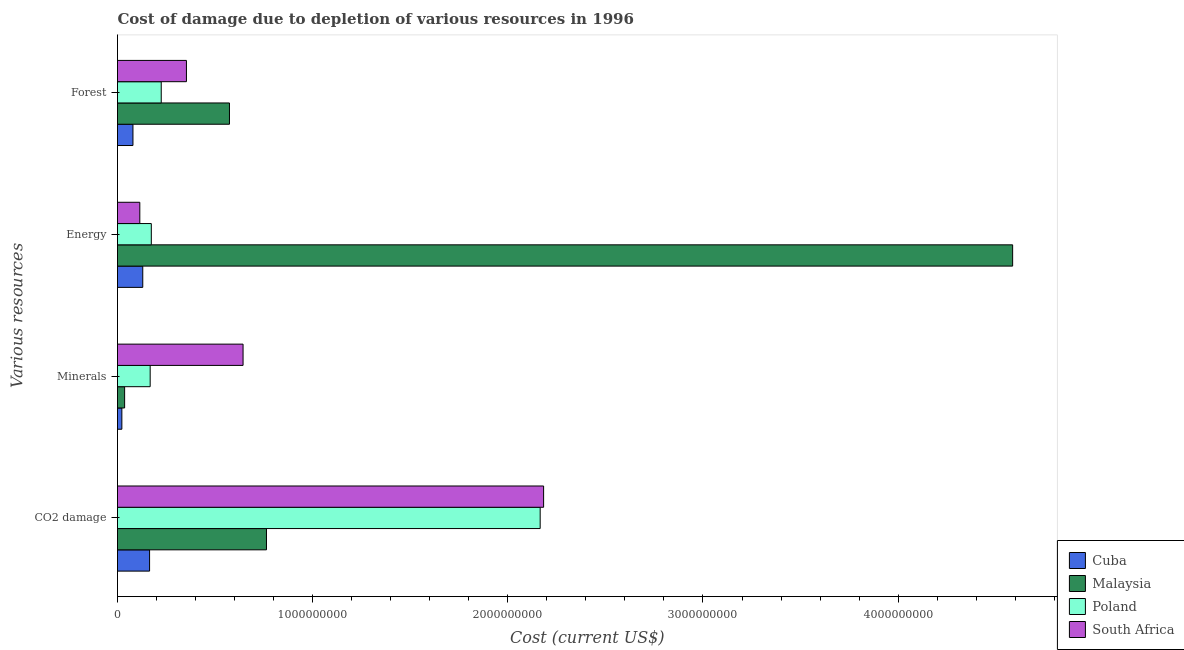Are the number of bars per tick equal to the number of legend labels?
Make the answer very short. Yes. Are the number of bars on each tick of the Y-axis equal?
Provide a succinct answer. Yes. How many bars are there on the 2nd tick from the top?
Provide a short and direct response. 4. How many bars are there on the 2nd tick from the bottom?
Offer a terse response. 4. What is the label of the 2nd group of bars from the top?
Make the answer very short. Energy. What is the cost of damage due to depletion of minerals in Malaysia?
Keep it short and to the point. 3.65e+07. Across all countries, what is the maximum cost of damage due to depletion of coal?
Your response must be concise. 2.18e+09. Across all countries, what is the minimum cost of damage due to depletion of coal?
Offer a terse response. 1.64e+08. In which country was the cost of damage due to depletion of minerals maximum?
Ensure brevity in your answer.  South Africa. In which country was the cost of damage due to depletion of forests minimum?
Offer a terse response. Cuba. What is the total cost of damage due to depletion of energy in the graph?
Your response must be concise. 5.00e+09. What is the difference between the cost of damage due to depletion of minerals in Cuba and that in Poland?
Your answer should be compact. -1.45e+08. What is the difference between the cost of damage due to depletion of minerals in Cuba and the cost of damage due to depletion of forests in Poland?
Provide a short and direct response. -2.02e+08. What is the average cost of damage due to depletion of minerals per country?
Your response must be concise. 2.17e+08. What is the difference between the cost of damage due to depletion of forests and cost of damage due to depletion of minerals in Cuba?
Provide a succinct answer. 5.68e+07. What is the ratio of the cost of damage due to depletion of energy in South Africa to that in Cuba?
Ensure brevity in your answer.  0.88. Is the difference between the cost of damage due to depletion of energy in Poland and South Africa greater than the difference between the cost of damage due to depletion of coal in Poland and South Africa?
Offer a very short reply. Yes. What is the difference between the highest and the second highest cost of damage due to depletion of energy?
Your response must be concise. 4.41e+09. What is the difference between the highest and the lowest cost of damage due to depletion of minerals?
Provide a short and direct response. 6.21e+08. Is it the case that in every country, the sum of the cost of damage due to depletion of energy and cost of damage due to depletion of coal is greater than the sum of cost of damage due to depletion of minerals and cost of damage due to depletion of forests?
Offer a terse response. No. Is it the case that in every country, the sum of the cost of damage due to depletion of coal and cost of damage due to depletion of minerals is greater than the cost of damage due to depletion of energy?
Your response must be concise. No. How many bars are there?
Your response must be concise. 16. How many countries are there in the graph?
Your answer should be very brief. 4. What is the difference between two consecutive major ticks on the X-axis?
Make the answer very short. 1.00e+09. Does the graph contain any zero values?
Keep it short and to the point. No. Does the graph contain grids?
Ensure brevity in your answer.  No. What is the title of the graph?
Provide a succinct answer. Cost of damage due to depletion of various resources in 1996 . What is the label or title of the X-axis?
Offer a very short reply. Cost (current US$). What is the label or title of the Y-axis?
Give a very brief answer. Various resources. What is the Cost (current US$) of Cuba in CO2 damage?
Your answer should be very brief. 1.64e+08. What is the Cost (current US$) of Malaysia in CO2 damage?
Your response must be concise. 7.63e+08. What is the Cost (current US$) in Poland in CO2 damage?
Provide a short and direct response. 2.17e+09. What is the Cost (current US$) of South Africa in CO2 damage?
Offer a very short reply. 2.18e+09. What is the Cost (current US$) of Cuba in Minerals?
Ensure brevity in your answer.  2.23e+07. What is the Cost (current US$) of Malaysia in Minerals?
Provide a short and direct response. 3.65e+07. What is the Cost (current US$) of Poland in Minerals?
Keep it short and to the point. 1.67e+08. What is the Cost (current US$) in South Africa in Minerals?
Give a very brief answer. 6.43e+08. What is the Cost (current US$) of Cuba in Energy?
Offer a terse response. 1.29e+08. What is the Cost (current US$) of Malaysia in Energy?
Your answer should be compact. 4.59e+09. What is the Cost (current US$) of Poland in Energy?
Your response must be concise. 1.73e+08. What is the Cost (current US$) of South Africa in Energy?
Your response must be concise. 1.14e+08. What is the Cost (current US$) in Cuba in Forest?
Offer a very short reply. 7.91e+07. What is the Cost (current US$) in Malaysia in Forest?
Your response must be concise. 5.74e+08. What is the Cost (current US$) in Poland in Forest?
Offer a terse response. 2.24e+08. What is the Cost (current US$) of South Africa in Forest?
Offer a terse response. 3.53e+08. Across all Various resources, what is the maximum Cost (current US$) in Cuba?
Provide a short and direct response. 1.64e+08. Across all Various resources, what is the maximum Cost (current US$) in Malaysia?
Your answer should be compact. 4.59e+09. Across all Various resources, what is the maximum Cost (current US$) of Poland?
Your response must be concise. 2.17e+09. Across all Various resources, what is the maximum Cost (current US$) of South Africa?
Offer a very short reply. 2.18e+09. Across all Various resources, what is the minimum Cost (current US$) of Cuba?
Make the answer very short. 2.23e+07. Across all Various resources, what is the minimum Cost (current US$) in Malaysia?
Offer a very short reply. 3.65e+07. Across all Various resources, what is the minimum Cost (current US$) in Poland?
Offer a very short reply. 1.67e+08. Across all Various resources, what is the minimum Cost (current US$) in South Africa?
Keep it short and to the point. 1.14e+08. What is the total Cost (current US$) in Cuba in the graph?
Provide a short and direct response. 3.95e+08. What is the total Cost (current US$) of Malaysia in the graph?
Give a very brief answer. 5.96e+09. What is the total Cost (current US$) in Poland in the graph?
Your answer should be compact. 2.73e+09. What is the total Cost (current US$) in South Africa in the graph?
Your answer should be very brief. 3.29e+09. What is the difference between the Cost (current US$) of Cuba in CO2 damage and that in Minerals?
Ensure brevity in your answer.  1.42e+08. What is the difference between the Cost (current US$) in Malaysia in CO2 damage and that in Minerals?
Give a very brief answer. 7.27e+08. What is the difference between the Cost (current US$) of Poland in CO2 damage and that in Minerals?
Offer a terse response. 2.00e+09. What is the difference between the Cost (current US$) in South Africa in CO2 damage and that in Minerals?
Your answer should be compact. 1.54e+09. What is the difference between the Cost (current US$) of Cuba in CO2 damage and that in Energy?
Your response must be concise. 3.49e+07. What is the difference between the Cost (current US$) in Malaysia in CO2 damage and that in Energy?
Your answer should be very brief. -3.82e+09. What is the difference between the Cost (current US$) in Poland in CO2 damage and that in Energy?
Make the answer very short. 1.99e+09. What is the difference between the Cost (current US$) in South Africa in CO2 damage and that in Energy?
Keep it short and to the point. 2.07e+09. What is the difference between the Cost (current US$) in Cuba in CO2 damage and that in Forest?
Your answer should be compact. 8.52e+07. What is the difference between the Cost (current US$) of Malaysia in CO2 damage and that in Forest?
Ensure brevity in your answer.  1.90e+08. What is the difference between the Cost (current US$) of Poland in CO2 damage and that in Forest?
Your answer should be very brief. 1.94e+09. What is the difference between the Cost (current US$) of South Africa in CO2 damage and that in Forest?
Keep it short and to the point. 1.83e+09. What is the difference between the Cost (current US$) in Cuba in Minerals and that in Energy?
Provide a short and direct response. -1.07e+08. What is the difference between the Cost (current US$) in Malaysia in Minerals and that in Energy?
Your answer should be compact. -4.55e+09. What is the difference between the Cost (current US$) of Poland in Minerals and that in Energy?
Your answer should be compact. -5.83e+06. What is the difference between the Cost (current US$) of South Africa in Minerals and that in Energy?
Make the answer very short. 5.29e+08. What is the difference between the Cost (current US$) of Cuba in Minerals and that in Forest?
Your response must be concise. -5.68e+07. What is the difference between the Cost (current US$) of Malaysia in Minerals and that in Forest?
Keep it short and to the point. -5.37e+08. What is the difference between the Cost (current US$) in Poland in Minerals and that in Forest?
Ensure brevity in your answer.  -5.67e+07. What is the difference between the Cost (current US$) in South Africa in Minerals and that in Forest?
Provide a short and direct response. 2.90e+08. What is the difference between the Cost (current US$) of Cuba in Energy and that in Forest?
Provide a short and direct response. 5.03e+07. What is the difference between the Cost (current US$) of Malaysia in Energy and that in Forest?
Offer a terse response. 4.01e+09. What is the difference between the Cost (current US$) in Poland in Energy and that in Forest?
Offer a very short reply. -5.09e+07. What is the difference between the Cost (current US$) of South Africa in Energy and that in Forest?
Your answer should be compact. -2.39e+08. What is the difference between the Cost (current US$) of Cuba in CO2 damage and the Cost (current US$) of Malaysia in Minerals?
Keep it short and to the point. 1.28e+08. What is the difference between the Cost (current US$) in Cuba in CO2 damage and the Cost (current US$) in Poland in Minerals?
Make the answer very short. -3.02e+06. What is the difference between the Cost (current US$) of Cuba in CO2 damage and the Cost (current US$) of South Africa in Minerals?
Offer a terse response. -4.79e+08. What is the difference between the Cost (current US$) in Malaysia in CO2 damage and the Cost (current US$) in Poland in Minerals?
Keep it short and to the point. 5.96e+08. What is the difference between the Cost (current US$) in Malaysia in CO2 damage and the Cost (current US$) in South Africa in Minerals?
Offer a very short reply. 1.20e+08. What is the difference between the Cost (current US$) in Poland in CO2 damage and the Cost (current US$) in South Africa in Minerals?
Ensure brevity in your answer.  1.52e+09. What is the difference between the Cost (current US$) of Cuba in CO2 damage and the Cost (current US$) of Malaysia in Energy?
Provide a succinct answer. -4.42e+09. What is the difference between the Cost (current US$) in Cuba in CO2 damage and the Cost (current US$) in Poland in Energy?
Offer a terse response. -8.85e+06. What is the difference between the Cost (current US$) of Cuba in CO2 damage and the Cost (current US$) of South Africa in Energy?
Your response must be concise. 5.00e+07. What is the difference between the Cost (current US$) in Malaysia in CO2 damage and the Cost (current US$) in Poland in Energy?
Make the answer very short. 5.90e+08. What is the difference between the Cost (current US$) in Malaysia in CO2 damage and the Cost (current US$) in South Africa in Energy?
Provide a succinct answer. 6.49e+08. What is the difference between the Cost (current US$) of Poland in CO2 damage and the Cost (current US$) of South Africa in Energy?
Your answer should be very brief. 2.05e+09. What is the difference between the Cost (current US$) in Cuba in CO2 damage and the Cost (current US$) in Malaysia in Forest?
Ensure brevity in your answer.  -4.09e+08. What is the difference between the Cost (current US$) in Cuba in CO2 damage and the Cost (current US$) in Poland in Forest?
Your response must be concise. -5.97e+07. What is the difference between the Cost (current US$) of Cuba in CO2 damage and the Cost (current US$) of South Africa in Forest?
Your answer should be compact. -1.89e+08. What is the difference between the Cost (current US$) of Malaysia in CO2 damage and the Cost (current US$) of Poland in Forest?
Provide a short and direct response. 5.39e+08. What is the difference between the Cost (current US$) in Malaysia in CO2 damage and the Cost (current US$) in South Africa in Forest?
Ensure brevity in your answer.  4.10e+08. What is the difference between the Cost (current US$) in Poland in CO2 damage and the Cost (current US$) in South Africa in Forest?
Keep it short and to the point. 1.81e+09. What is the difference between the Cost (current US$) of Cuba in Minerals and the Cost (current US$) of Malaysia in Energy?
Your answer should be compact. -4.56e+09. What is the difference between the Cost (current US$) in Cuba in Minerals and the Cost (current US$) in Poland in Energy?
Provide a succinct answer. -1.51e+08. What is the difference between the Cost (current US$) in Cuba in Minerals and the Cost (current US$) in South Africa in Energy?
Give a very brief answer. -9.20e+07. What is the difference between the Cost (current US$) of Malaysia in Minerals and the Cost (current US$) of Poland in Energy?
Your response must be concise. -1.37e+08. What is the difference between the Cost (current US$) in Malaysia in Minerals and the Cost (current US$) in South Africa in Energy?
Offer a terse response. -7.79e+07. What is the difference between the Cost (current US$) of Poland in Minerals and the Cost (current US$) of South Africa in Energy?
Keep it short and to the point. 5.30e+07. What is the difference between the Cost (current US$) of Cuba in Minerals and the Cost (current US$) of Malaysia in Forest?
Offer a terse response. -5.51e+08. What is the difference between the Cost (current US$) of Cuba in Minerals and the Cost (current US$) of Poland in Forest?
Your response must be concise. -2.02e+08. What is the difference between the Cost (current US$) in Cuba in Minerals and the Cost (current US$) in South Africa in Forest?
Your response must be concise. -3.31e+08. What is the difference between the Cost (current US$) in Malaysia in Minerals and the Cost (current US$) in Poland in Forest?
Your answer should be compact. -1.88e+08. What is the difference between the Cost (current US$) of Malaysia in Minerals and the Cost (current US$) of South Africa in Forest?
Give a very brief answer. -3.17e+08. What is the difference between the Cost (current US$) in Poland in Minerals and the Cost (current US$) in South Africa in Forest?
Give a very brief answer. -1.86e+08. What is the difference between the Cost (current US$) of Cuba in Energy and the Cost (current US$) of Malaysia in Forest?
Keep it short and to the point. -4.44e+08. What is the difference between the Cost (current US$) in Cuba in Energy and the Cost (current US$) in Poland in Forest?
Offer a terse response. -9.46e+07. What is the difference between the Cost (current US$) in Cuba in Energy and the Cost (current US$) in South Africa in Forest?
Give a very brief answer. -2.24e+08. What is the difference between the Cost (current US$) of Malaysia in Energy and the Cost (current US$) of Poland in Forest?
Provide a short and direct response. 4.36e+09. What is the difference between the Cost (current US$) of Malaysia in Energy and the Cost (current US$) of South Africa in Forest?
Give a very brief answer. 4.23e+09. What is the difference between the Cost (current US$) in Poland in Energy and the Cost (current US$) in South Africa in Forest?
Your response must be concise. -1.80e+08. What is the average Cost (current US$) in Cuba per Various resources?
Your answer should be compact. 9.88e+07. What is the average Cost (current US$) in Malaysia per Various resources?
Ensure brevity in your answer.  1.49e+09. What is the average Cost (current US$) in Poland per Various resources?
Offer a very short reply. 6.83e+08. What is the average Cost (current US$) in South Africa per Various resources?
Provide a succinct answer. 8.24e+08. What is the difference between the Cost (current US$) of Cuba and Cost (current US$) of Malaysia in CO2 damage?
Offer a very short reply. -5.99e+08. What is the difference between the Cost (current US$) in Cuba and Cost (current US$) in Poland in CO2 damage?
Your response must be concise. -2.00e+09. What is the difference between the Cost (current US$) in Cuba and Cost (current US$) in South Africa in CO2 damage?
Give a very brief answer. -2.02e+09. What is the difference between the Cost (current US$) of Malaysia and Cost (current US$) of Poland in CO2 damage?
Offer a very short reply. -1.40e+09. What is the difference between the Cost (current US$) of Malaysia and Cost (current US$) of South Africa in CO2 damage?
Give a very brief answer. -1.42e+09. What is the difference between the Cost (current US$) of Poland and Cost (current US$) of South Africa in CO2 damage?
Offer a terse response. -1.76e+07. What is the difference between the Cost (current US$) of Cuba and Cost (current US$) of Malaysia in Minerals?
Keep it short and to the point. -1.42e+07. What is the difference between the Cost (current US$) in Cuba and Cost (current US$) in Poland in Minerals?
Keep it short and to the point. -1.45e+08. What is the difference between the Cost (current US$) in Cuba and Cost (current US$) in South Africa in Minerals?
Offer a very short reply. -6.21e+08. What is the difference between the Cost (current US$) of Malaysia and Cost (current US$) of Poland in Minerals?
Your response must be concise. -1.31e+08. What is the difference between the Cost (current US$) of Malaysia and Cost (current US$) of South Africa in Minerals?
Your response must be concise. -6.07e+08. What is the difference between the Cost (current US$) in Poland and Cost (current US$) in South Africa in Minerals?
Offer a terse response. -4.76e+08. What is the difference between the Cost (current US$) of Cuba and Cost (current US$) of Malaysia in Energy?
Give a very brief answer. -4.46e+09. What is the difference between the Cost (current US$) in Cuba and Cost (current US$) in Poland in Energy?
Offer a terse response. -4.38e+07. What is the difference between the Cost (current US$) in Cuba and Cost (current US$) in South Africa in Energy?
Your answer should be very brief. 1.51e+07. What is the difference between the Cost (current US$) in Malaysia and Cost (current US$) in Poland in Energy?
Offer a terse response. 4.41e+09. What is the difference between the Cost (current US$) of Malaysia and Cost (current US$) of South Africa in Energy?
Give a very brief answer. 4.47e+09. What is the difference between the Cost (current US$) in Poland and Cost (current US$) in South Africa in Energy?
Give a very brief answer. 5.89e+07. What is the difference between the Cost (current US$) in Cuba and Cost (current US$) in Malaysia in Forest?
Your response must be concise. -4.95e+08. What is the difference between the Cost (current US$) in Cuba and Cost (current US$) in Poland in Forest?
Give a very brief answer. -1.45e+08. What is the difference between the Cost (current US$) in Cuba and Cost (current US$) in South Africa in Forest?
Offer a very short reply. -2.74e+08. What is the difference between the Cost (current US$) of Malaysia and Cost (current US$) of Poland in Forest?
Give a very brief answer. 3.50e+08. What is the difference between the Cost (current US$) in Malaysia and Cost (current US$) in South Africa in Forest?
Offer a terse response. 2.20e+08. What is the difference between the Cost (current US$) in Poland and Cost (current US$) in South Africa in Forest?
Give a very brief answer. -1.29e+08. What is the ratio of the Cost (current US$) of Cuba in CO2 damage to that in Minerals?
Your answer should be very brief. 7.37. What is the ratio of the Cost (current US$) in Malaysia in CO2 damage to that in Minerals?
Ensure brevity in your answer.  20.93. What is the ratio of the Cost (current US$) in Poland in CO2 damage to that in Minerals?
Your response must be concise. 12.94. What is the ratio of the Cost (current US$) of South Africa in CO2 damage to that in Minerals?
Offer a very short reply. 3.39. What is the ratio of the Cost (current US$) of Cuba in CO2 damage to that in Energy?
Give a very brief answer. 1.27. What is the ratio of the Cost (current US$) in Malaysia in CO2 damage to that in Energy?
Your answer should be compact. 0.17. What is the ratio of the Cost (current US$) in Poland in CO2 damage to that in Energy?
Provide a short and direct response. 12.5. What is the ratio of the Cost (current US$) in South Africa in CO2 damage to that in Energy?
Your response must be concise. 19.1. What is the ratio of the Cost (current US$) of Cuba in CO2 damage to that in Forest?
Ensure brevity in your answer.  2.08. What is the ratio of the Cost (current US$) in Malaysia in CO2 damage to that in Forest?
Give a very brief answer. 1.33. What is the ratio of the Cost (current US$) in Poland in CO2 damage to that in Forest?
Ensure brevity in your answer.  9.66. What is the ratio of the Cost (current US$) of South Africa in CO2 damage to that in Forest?
Make the answer very short. 6.18. What is the ratio of the Cost (current US$) of Cuba in Minerals to that in Energy?
Offer a terse response. 0.17. What is the ratio of the Cost (current US$) of Malaysia in Minerals to that in Energy?
Provide a succinct answer. 0.01. What is the ratio of the Cost (current US$) in Poland in Minerals to that in Energy?
Give a very brief answer. 0.97. What is the ratio of the Cost (current US$) of South Africa in Minerals to that in Energy?
Provide a short and direct response. 5.63. What is the ratio of the Cost (current US$) of Cuba in Minerals to that in Forest?
Ensure brevity in your answer.  0.28. What is the ratio of the Cost (current US$) of Malaysia in Minerals to that in Forest?
Provide a succinct answer. 0.06. What is the ratio of the Cost (current US$) in Poland in Minerals to that in Forest?
Ensure brevity in your answer.  0.75. What is the ratio of the Cost (current US$) in South Africa in Minerals to that in Forest?
Provide a succinct answer. 1.82. What is the ratio of the Cost (current US$) of Cuba in Energy to that in Forest?
Offer a very short reply. 1.64. What is the ratio of the Cost (current US$) in Malaysia in Energy to that in Forest?
Provide a succinct answer. 8. What is the ratio of the Cost (current US$) in Poland in Energy to that in Forest?
Your response must be concise. 0.77. What is the ratio of the Cost (current US$) of South Africa in Energy to that in Forest?
Your response must be concise. 0.32. What is the difference between the highest and the second highest Cost (current US$) in Cuba?
Provide a short and direct response. 3.49e+07. What is the difference between the highest and the second highest Cost (current US$) in Malaysia?
Your answer should be very brief. 3.82e+09. What is the difference between the highest and the second highest Cost (current US$) in Poland?
Make the answer very short. 1.94e+09. What is the difference between the highest and the second highest Cost (current US$) of South Africa?
Your response must be concise. 1.54e+09. What is the difference between the highest and the lowest Cost (current US$) of Cuba?
Provide a succinct answer. 1.42e+08. What is the difference between the highest and the lowest Cost (current US$) in Malaysia?
Ensure brevity in your answer.  4.55e+09. What is the difference between the highest and the lowest Cost (current US$) in Poland?
Ensure brevity in your answer.  2.00e+09. What is the difference between the highest and the lowest Cost (current US$) of South Africa?
Keep it short and to the point. 2.07e+09. 